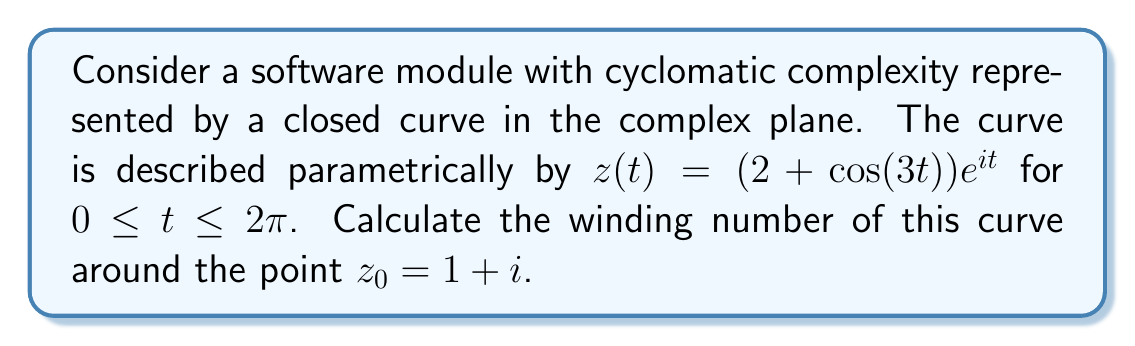Teach me how to tackle this problem. To calculate the winding number of the given curve around the point $z_0 = 1 + i$, we'll use the formula:

$$n(z_0) = \frac{1}{2\pi i} \oint_C \frac{dz}{z - z_0}$$

Where $C$ is our given curve.

Step 1: Calculate $dz/dt$
$$\frac{dz}{dt} = (-3\sin(3t))e^{it} + i(2 + \cos(3t))e^{it}$$

Step 2: Express $z - z_0$
$$z - z_0 = (2 + \cos(3t))e^{it} - (1 + i)$$

Step 3: Set up the integral
$$n(z_0) = \frac{1}{2\pi i} \int_0^{2\pi} \frac{(-3\sin(3t))e^{it} + i(2 + \cos(3t))e^{it}}{(2 + \cos(3t))e^{it} - (1 + i)} dt$$

Step 4: Simplify the integrand
Let $w = e^{it}$, then $dw = ie^{it}dt = iwdt$
$$n(z_0) = \frac{1}{2\pi} \oint_C \frac{-3\sin(3t) + i(2 + \cos(3t))}{(2 + \cos(3t))w - (1 + i)} dw$$

Step 5: Use the Argument Principle
The winding number is equal to the number of zeros minus the number of poles of the function inside the curve. In this case, we're looking at:

$$f(w) = \frac{(2 + \cos(3t))w - (1 + i)}{w}$$

This function has one zero at $w = \frac{1+i}{2+\cos(3t)}$ and one pole at $w = 0$.

Step 6: Determine if the zero and pole are inside the curve
The curve $|w| = 2 + \cos(3t)$ always has $|w| \geq 1$, so the pole at $w = 0$ is always inside the curve.

For the zero, we need to check if $|\frac{1+i}{2+\cos(3t)}| < 1$ for all $t$:

$$|\frac{1+i}{2+\cos(3t)}|^2 = \frac{2}{(2+\cos(3t))^2} \leq \frac{2}{1^2} = 2 < 1$$

This is not always true, so the zero is not always inside the curve.

Therefore, the winding number is -1 (one pole inside, no zeros inside).
Answer: The winding number of the curve around the point $z_0 = 1 + i$ is $-1$. 